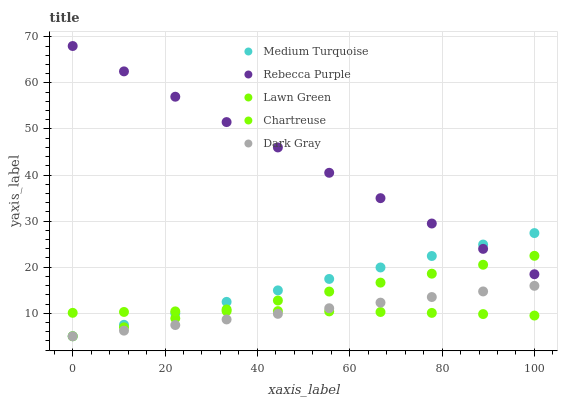Does Chartreuse have the minimum area under the curve?
Answer yes or no. Yes. Does Rebecca Purple have the maximum area under the curve?
Answer yes or no. Yes. Does Lawn Green have the minimum area under the curve?
Answer yes or no. No. Does Lawn Green have the maximum area under the curve?
Answer yes or no. No. Is Dark Gray the smoothest?
Answer yes or no. Yes. Is Chartreuse the roughest?
Answer yes or no. Yes. Is Lawn Green the smoothest?
Answer yes or no. No. Is Lawn Green the roughest?
Answer yes or no. No. Does Dark Gray have the lowest value?
Answer yes or no. Yes. Does Chartreuse have the lowest value?
Answer yes or no. No. Does Rebecca Purple have the highest value?
Answer yes or no. Yes. Does Lawn Green have the highest value?
Answer yes or no. No. Is Dark Gray less than Rebecca Purple?
Answer yes or no. Yes. Is Rebecca Purple greater than Chartreuse?
Answer yes or no. Yes. Does Lawn Green intersect Rebecca Purple?
Answer yes or no. Yes. Is Lawn Green less than Rebecca Purple?
Answer yes or no. No. Is Lawn Green greater than Rebecca Purple?
Answer yes or no. No. Does Dark Gray intersect Rebecca Purple?
Answer yes or no. No. 